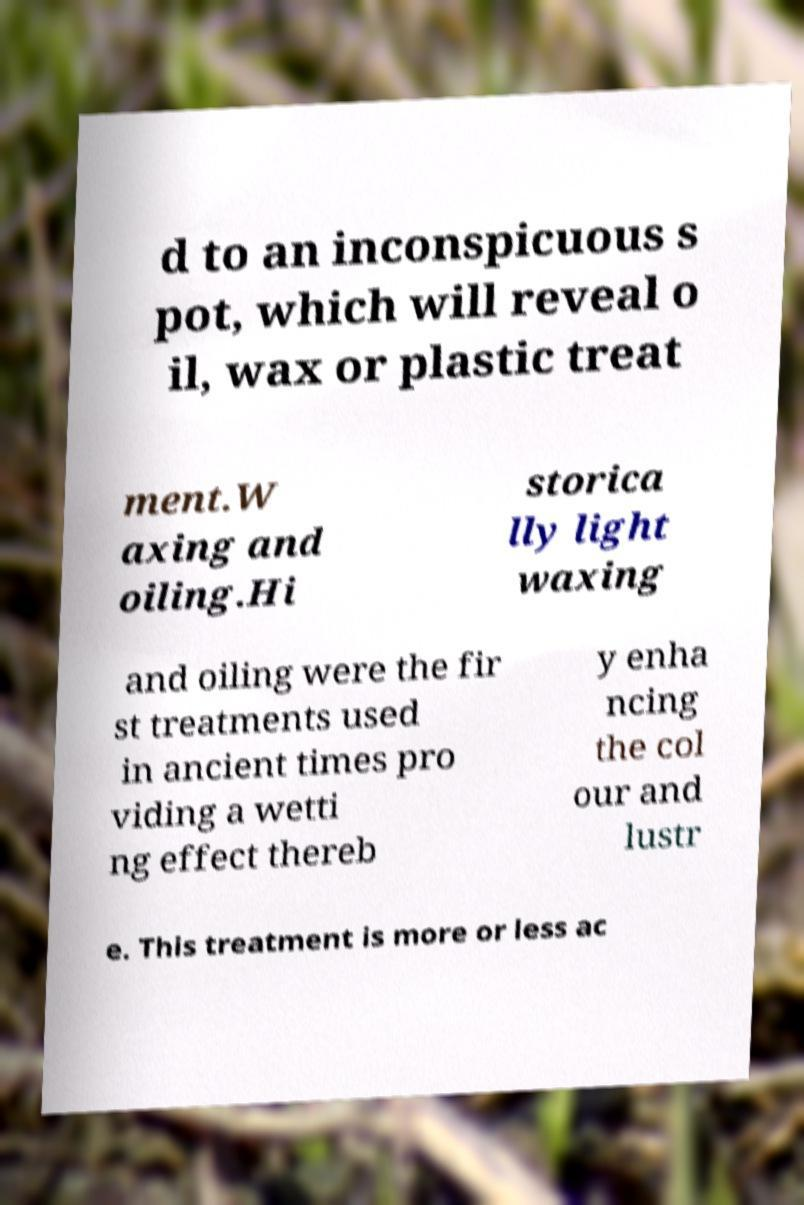What messages or text are displayed in this image? I need them in a readable, typed format. d to an inconspicuous s pot, which will reveal o il, wax or plastic treat ment.W axing and oiling.Hi storica lly light waxing and oiling were the fir st treatments used in ancient times pro viding a wetti ng effect thereb y enha ncing the col our and lustr e. This treatment is more or less ac 